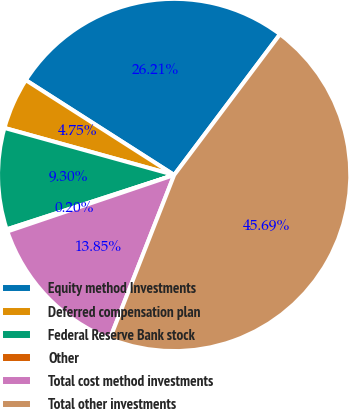<chart> <loc_0><loc_0><loc_500><loc_500><pie_chart><fcel>Equity method Investments<fcel>Deferred compensation plan<fcel>Federal Reserve Bank stock<fcel>Other<fcel>Total cost method investments<fcel>Total other investments<nl><fcel>26.21%<fcel>4.75%<fcel>9.3%<fcel>0.2%<fcel>13.85%<fcel>45.69%<nl></chart> 